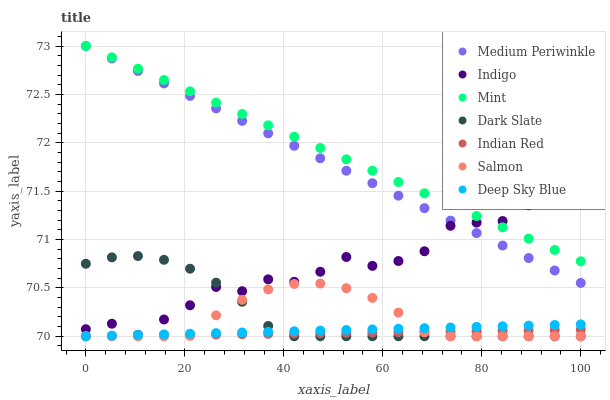Does Indian Red have the minimum area under the curve?
Answer yes or no. Yes. Does Mint have the maximum area under the curve?
Answer yes or no. Yes. Does Deep Sky Blue have the minimum area under the curve?
Answer yes or no. No. Does Deep Sky Blue have the maximum area under the curve?
Answer yes or no. No. Is Indian Red the smoothest?
Answer yes or no. Yes. Is Indigo the roughest?
Answer yes or no. Yes. Is Deep Sky Blue the smoothest?
Answer yes or no. No. Is Deep Sky Blue the roughest?
Answer yes or no. No. Does Deep Sky Blue have the lowest value?
Answer yes or no. Yes. Does Medium Periwinkle have the lowest value?
Answer yes or no. No. Does Mint have the highest value?
Answer yes or no. Yes. Does Deep Sky Blue have the highest value?
Answer yes or no. No. Is Indian Red less than Indigo?
Answer yes or no. Yes. Is Indigo greater than Indian Red?
Answer yes or no. Yes. Does Dark Slate intersect Deep Sky Blue?
Answer yes or no. Yes. Is Dark Slate less than Deep Sky Blue?
Answer yes or no. No. Is Dark Slate greater than Deep Sky Blue?
Answer yes or no. No. Does Indian Red intersect Indigo?
Answer yes or no. No. 